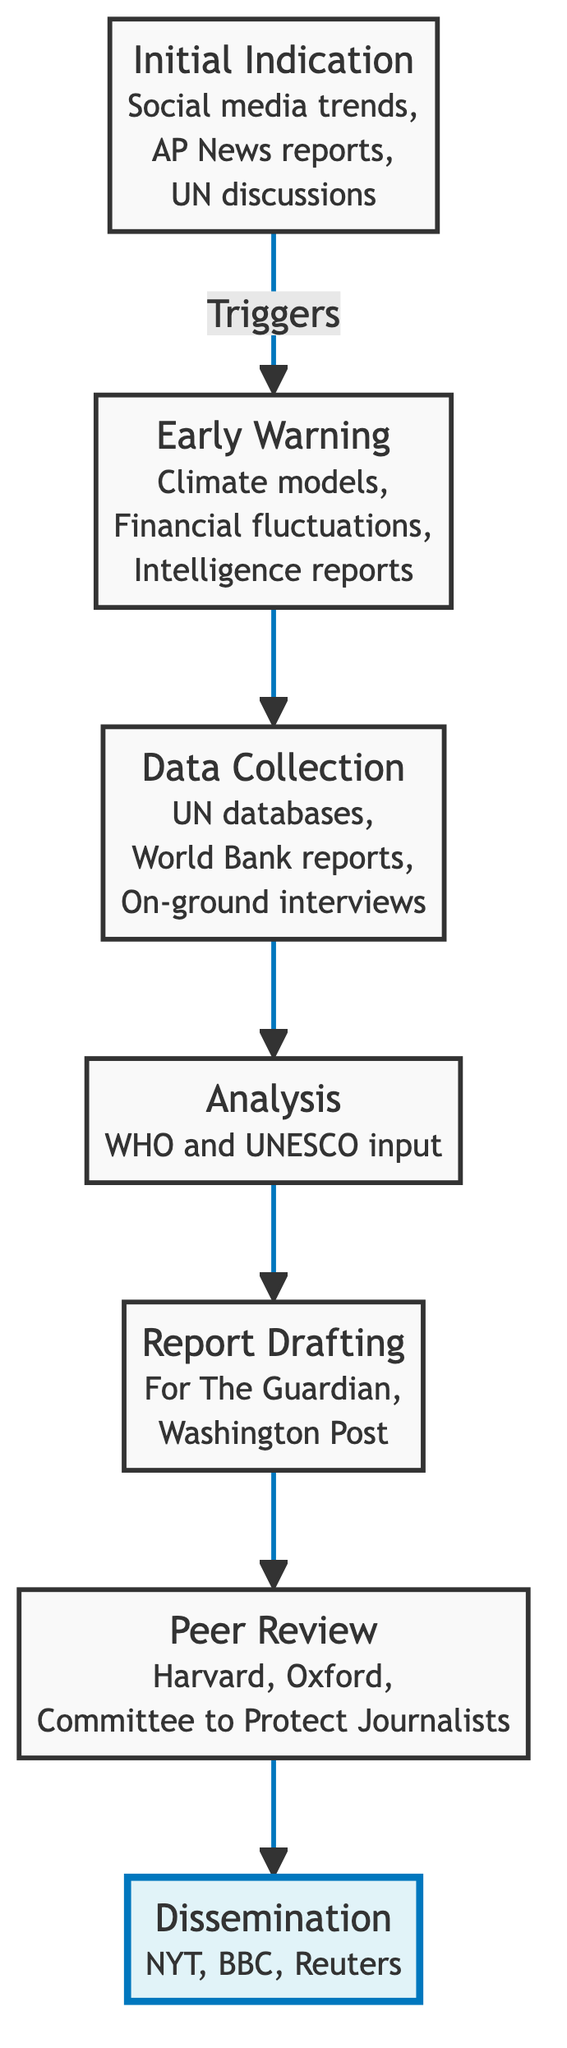What is the first step in the flow? The diagram indicates that the first step is "Initial Indication," which is positioned at the bottom of the chart.
Answer: Initial Indication How many steps are there in the analysis process? Counting all nodes in the flow from "Initial Indication" to "Dissemination," there are six steps in total.
Answer: Six What follows "Data Collection" in the flow? According to the diagram, "Data Collection" leads directly into "Analysis."
Answer: Analysis What are two sources mentioned for "Data Collection"? The diagram lists "UN databases" and "World Bank reports" as sources for data collection.
Answer: UN databases, World Bank reports Which step involves expert evaluation? The step designated for expert evaluation is labeled "Peer Review," which comes before "Dissemination."
Answer: Peer Review How does "Early Warning" relate to "Initial Indication"? "Early Warning" is a direct step that follows "Initial Indication," indicating that it is the next action after initial signs are noted.
Answer: Early Warning follows Initial Indication Which step is highlighted in the diagram? The highlight indicates that "Dissemination" is the emphasized step, suggesting its importance at the end of the process.
Answer: Dissemination What type of reports are prepared during "Report Drafting"? During "Report Drafting," comprehensive documents are prepared for publication in platforms such as "The Guardian" and "The Washington Post."
Answer: Comprehensive documents for The Guardian, Washington Post Which organizations provide input during the "Analysis" phase? The diagram specifies that input during the "Analysis" phase comes from the "World Health Organization" and "UNESCO."
Answer: World Health Organization, UNESCO 